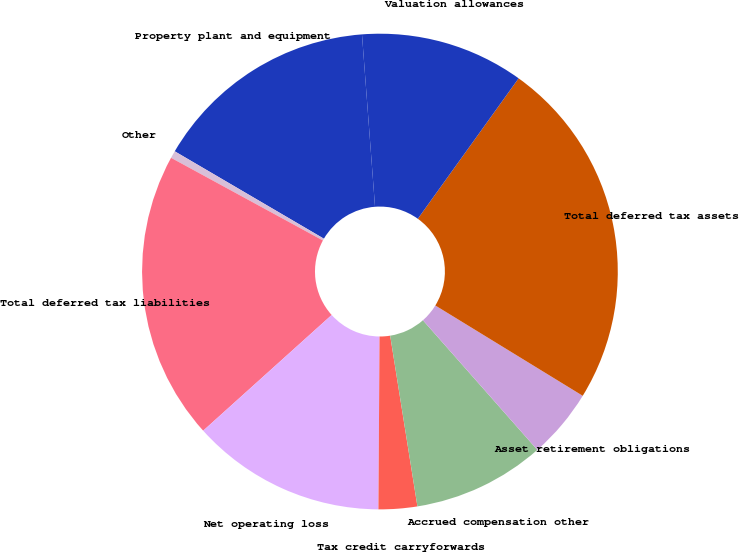Convert chart to OTSL. <chart><loc_0><loc_0><loc_500><loc_500><pie_chart><fcel>Property plant and equipment<fcel>Other<fcel>Total deferred tax liabilities<fcel>Net operating loss<fcel>Tax credit carryforwards<fcel>Accrued compensation other<fcel>Asset retirement obligations<fcel>Total deferred tax assets<fcel>Valuation allowances<nl><fcel>15.36%<fcel>0.5%<fcel>19.6%<fcel>13.23%<fcel>2.62%<fcel>8.99%<fcel>4.74%<fcel>23.84%<fcel>11.11%<nl></chart> 